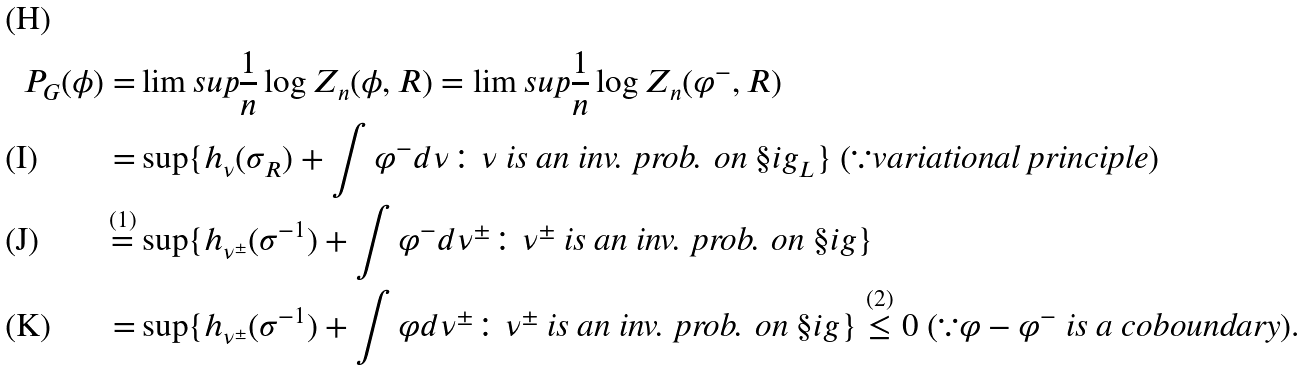<formula> <loc_0><loc_0><loc_500><loc_500>P _ { G } ( \phi ) = & \lim s u p \frac { 1 } { n } \log Z _ { n } ( \phi , R ) = \lim s u p \frac { 1 } { n } \log Z _ { n } ( \varphi ^ { - } , R ) \\ = & \sup \{ h _ { \nu } ( \sigma _ { R } ) + \int \varphi ^ { - } d \nu \colon \nu \text { is an inv. prob. on } \S i g _ { L } \} \text { } ( \because \text {variational principle} ) \\ \stackrel { ( 1 ) } { = } & \sup \{ h _ { \nu ^ { \pm } } ( \sigma ^ { - 1 } ) + \int \varphi ^ { - } d \nu ^ { \pm } \colon \nu ^ { \pm } \text { is an inv. prob. on } \S i g \} \\ = & \sup \{ h _ { \nu ^ { \pm } } ( \sigma ^ { - 1 } ) + \int \varphi d \nu ^ { \pm } \colon \nu ^ { \pm } \text { is an inv. prob. on } \S i g \} \stackrel { ( 2 ) } { \leq } 0 \text { } ( \because \varphi - \varphi ^ { - } \text { is a coboundary} ) .</formula> 